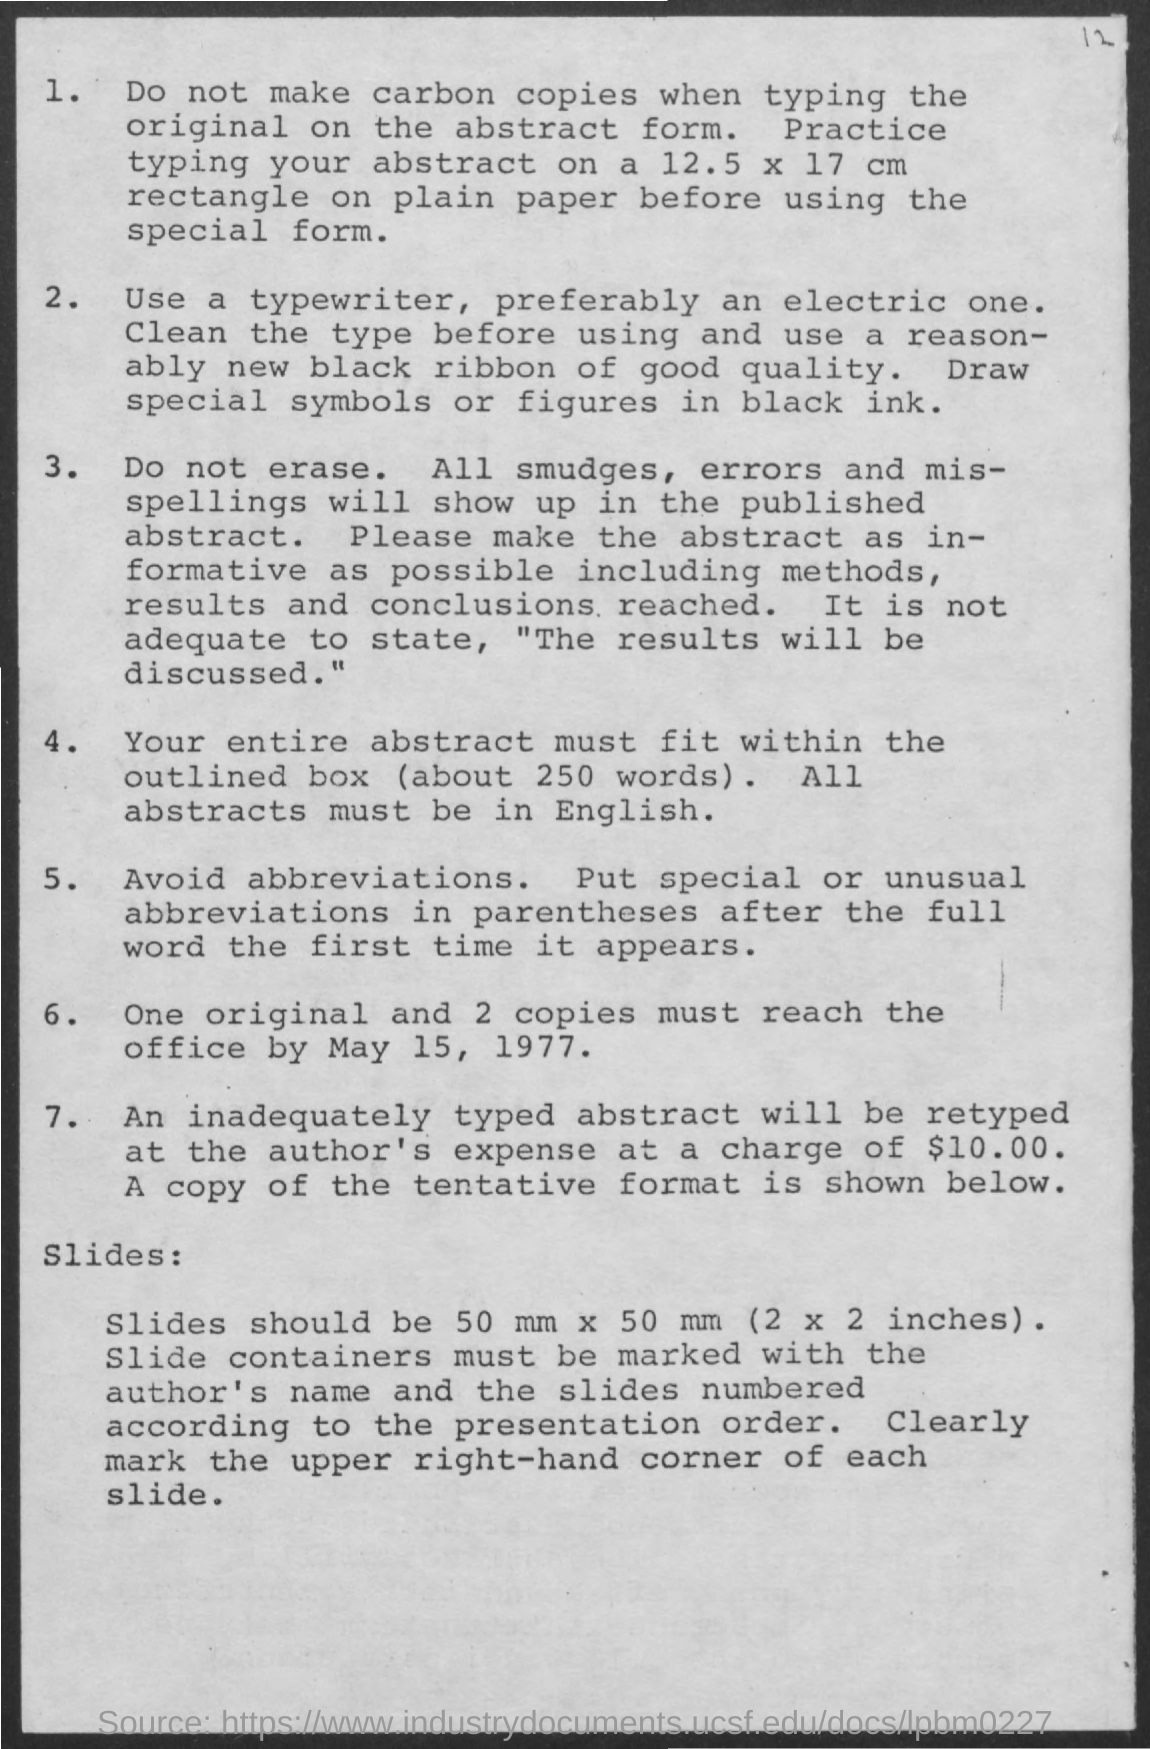What is charge for retyping?
Your answer should be compact. $10.00. What is the paper size for typing abstract?
Your response must be concise. 12.5 x 17 cm. What type of typewriter is preferred?
Give a very brief answer. Electric. What should be the language of abstract?
Give a very brief answer. English. 